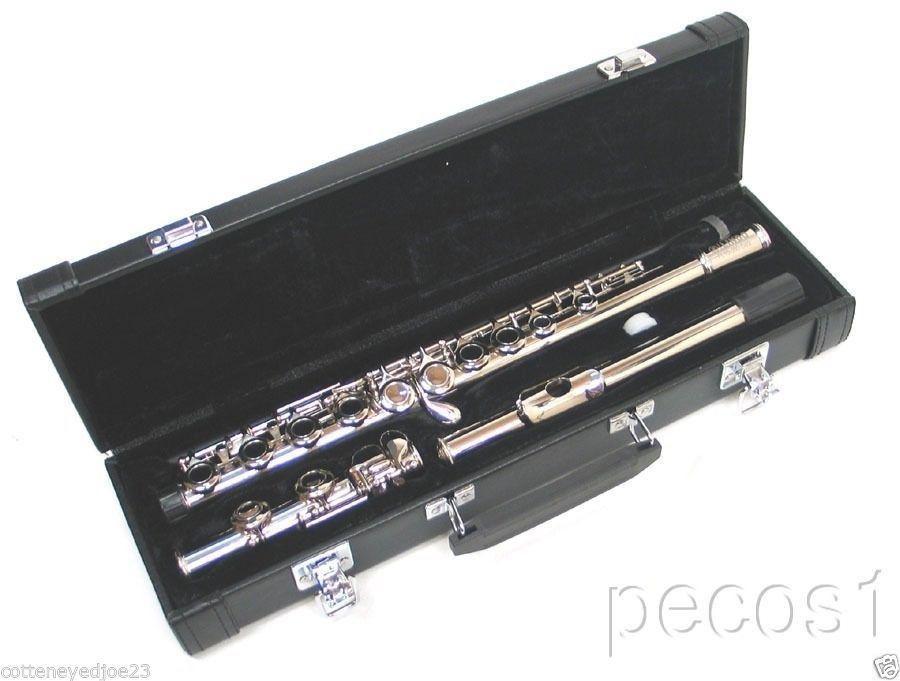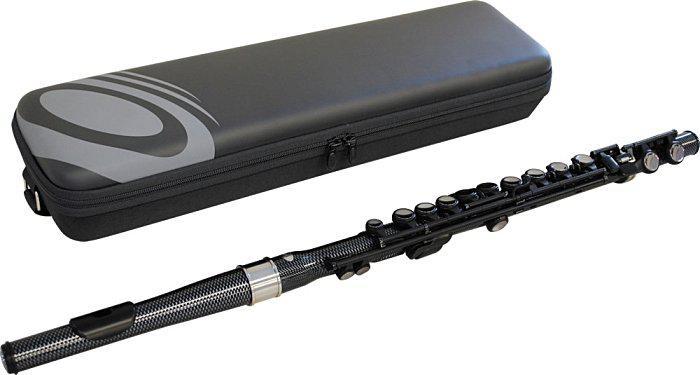The first image is the image on the left, the second image is the image on the right. For the images displayed, is the sentence "In the image pair there are two flutes propped over their carrying cases" factually correct? Answer yes or no. No. The first image is the image on the left, the second image is the image on the right. Evaluate the accuracy of this statement regarding the images: "One of the instrument cases is completely closed.". Is it true? Answer yes or no. Yes. 